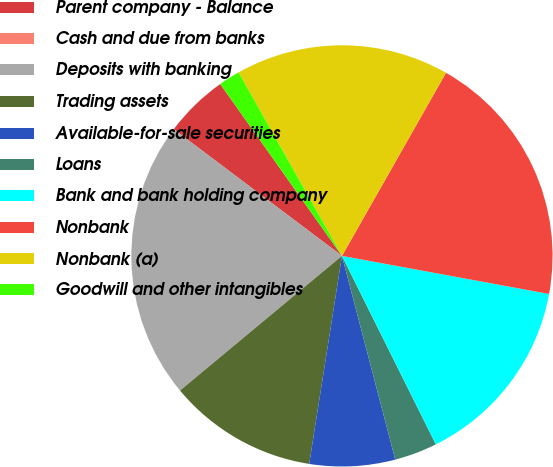Convert chart. <chart><loc_0><loc_0><loc_500><loc_500><pie_chart><fcel>Parent company - Balance<fcel>Cash and due from banks<fcel>Deposits with banking<fcel>Trading assets<fcel>Available-for-sale securities<fcel>Loans<fcel>Bank and bank holding company<fcel>Nonbank<fcel>Nonbank (a)<fcel>Goodwill and other intangibles<nl><fcel>4.92%<fcel>0.0%<fcel>21.31%<fcel>11.47%<fcel>6.56%<fcel>3.28%<fcel>14.75%<fcel>19.67%<fcel>16.39%<fcel>1.64%<nl></chart> 